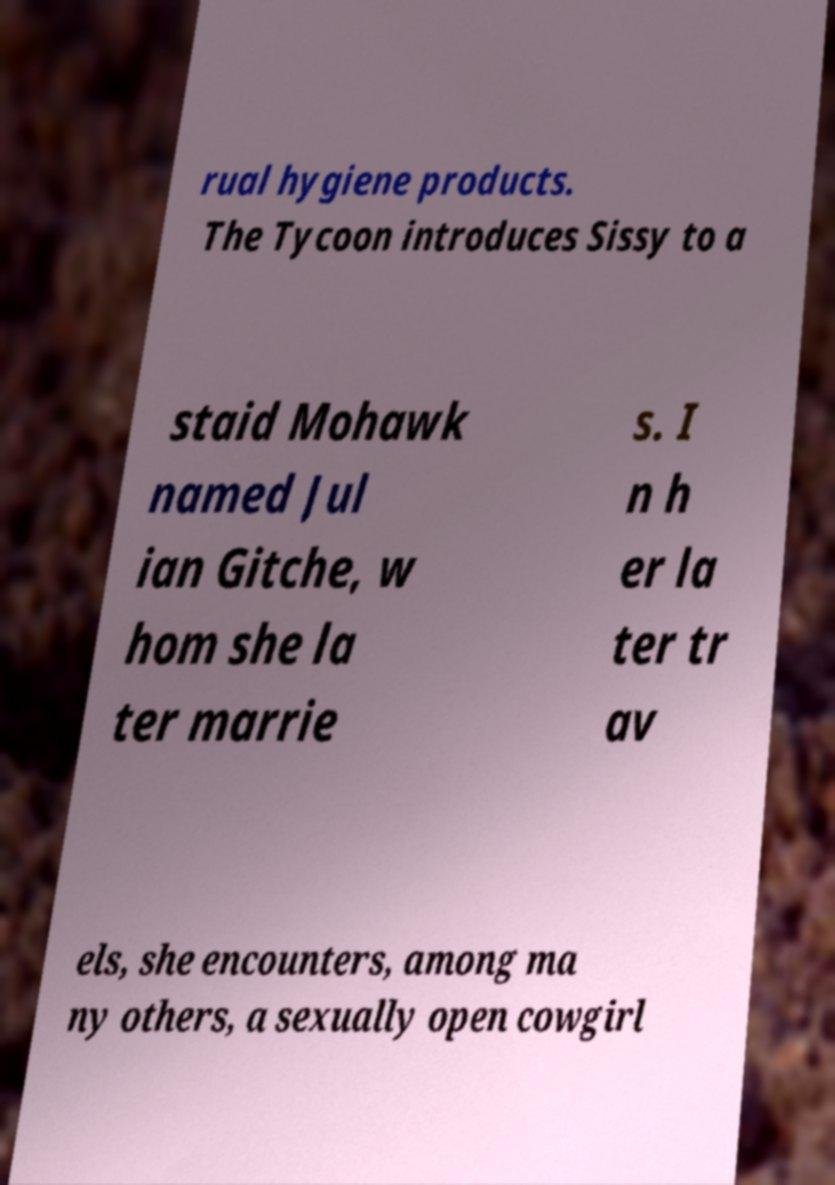What messages or text are displayed in this image? I need them in a readable, typed format. rual hygiene products. The Tycoon introduces Sissy to a staid Mohawk named Jul ian Gitche, w hom she la ter marrie s. I n h er la ter tr av els, she encounters, among ma ny others, a sexually open cowgirl 